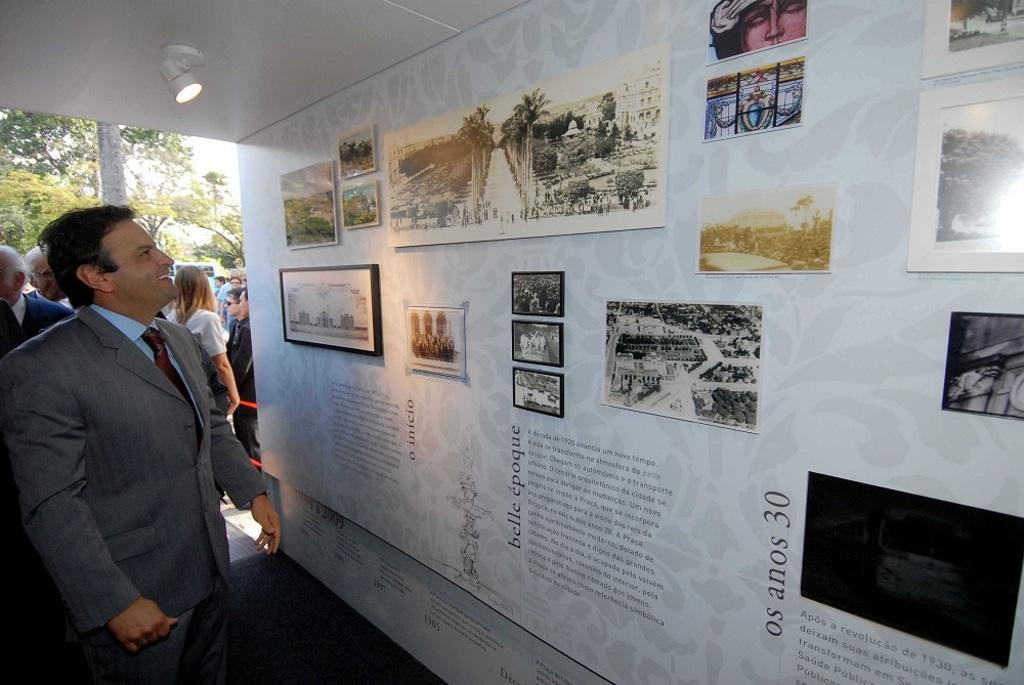How many people are present in the image? There are people in the image, but the exact number cannot be determined from the provided facts. What type of light is visible in the image? There is light in the image, but the specific source or type of light cannot be determined. What is the background of the image? The background of the image includes trees and sky. What is on the wall in the image? There is a wall in the image with frames and some information on it. What type of nail is being used to hang the pot on the wall in the image? There is no pot or nail present in the image; it only mentions frames and information on the wall. What type of bread is being served at the event in the image? There is no event or bread mentioned in the image; it only mentions people, light, a wall, trees, sky, frames, and information on the wall. 